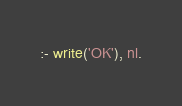<code> <loc_0><loc_0><loc_500><loc_500><_Prolog_>:- write('OK'), nl.</code> 